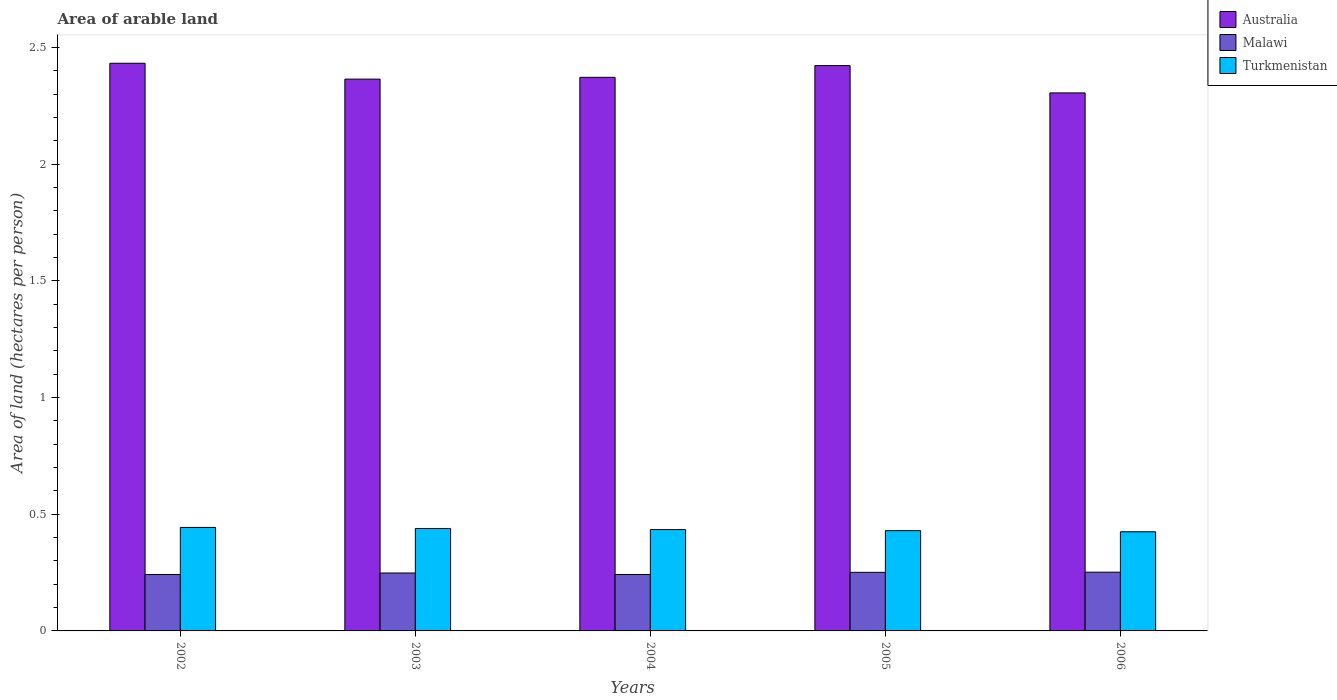Are the number of bars per tick equal to the number of legend labels?
Keep it short and to the point. Yes. Are the number of bars on each tick of the X-axis equal?
Offer a terse response. Yes. In how many cases, is the number of bars for a given year not equal to the number of legend labels?
Provide a succinct answer. 0. What is the total arable land in Turkmenistan in 2005?
Your response must be concise. 0.43. Across all years, what is the maximum total arable land in Malawi?
Your answer should be very brief. 0.25. Across all years, what is the minimum total arable land in Australia?
Your answer should be compact. 2.31. In which year was the total arable land in Malawi maximum?
Keep it short and to the point. 2006. What is the total total arable land in Australia in the graph?
Give a very brief answer. 11.9. What is the difference between the total arable land in Malawi in 2002 and that in 2003?
Make the answer very short. -0.01. What is the difference between the total arable land in Malawi in 2003 and the total arable land in Turkmenistan in 2005?
Provide a succinct answer. -0.18. What is the average total arable land in Malawi per year?
Make the answer very short. 0.25. In the year 2004, what is the difference between the total arable land in Turkmenistan and total arable land in Australia?
Offer a very short reply. -1.94. What is the ratio of the total arable land in Malawi in 2003 to that in 2005?
Your answer should be very brief. 0.99. Is the total arable land in Turkmenistan in 2003 less than that in 2006?
Provide a short and direct response. No. Is the difference between the total arable land in Turkmenistan in 2002 and 2005 greater than the difference between the total arable land in Australia in 2002 and 2005?
Keep it short and to the point. Yes. What is the difference between the highest and the second highest total arable land in Australia?
Keep it short and to the point. 0.01. What is the difference between the highest and the lowest total arable land in Turkmenistan?
Your answer should be compact. 0.02. Is the sum of the total arable land in Turkmenistan in 2005 and 2006 greater than the maximum total arable land in Australia across all years?
Provide a short and direct response. No. What does the 3rd bar from the left in 2006 represents?
Your response must be concise. Turkmenistan. Is it the case that in every year, the sum of the total arable land in Turkmenistan and total arable land in Australia is greater than the total arable land in Malawi?
Your answer should be compact. Yes. How many bars are there?
Your answer should be compact. 15. Are all the bars in the graph horizontal?
Ensure brevity in your answer.  No. Where does the legend appear in the graph?
Keep it short and to the point. Top right. What is the title of the graph?
Ensure brevity in your answer.  Area of arable land. Does "Belarus" appear as one of the legend labels in the graph?
Make the answer very short. No. What is the label or title of the X-axis?
Give a very brief answer. Years. What is the label or title of the Y-axis?
Your response must be concise. Area of land (hectares per person). What is the Area of land (hectares per person) of Australia in 2002?
Ensure brevity in your answer.  2.43. What is the Area of land (hectares per person) of Malawi in 2002?
Your response must be concise. 0.24. What is the Area of land (hectares per person) in Turkmenistan in 2002?
Your response must be concise. 0.44. What is the Area of land (hectares per person) in Australia in 2003?
Your answer should be very brief. 2.36. What is the Area of land (hectares per person) in Malawi in 2003?
Offer a very short reply. 0.25. What is the Area of land (hectares per person) of Turkmenistan in 2003?
Provide a short and direct response. 0.44. What is the Area of land (hectares per person) in Australia in 2004?
Provide a short and direct response. 2.37. What is the Area of land (hectares per person) of Malawi in 2004?
Provide a succinct answer. 0.24. What is the Area of land (hectares per person) in Turkmenistan in 2004?
Ensure brevity in your answer.  0.43. What is the Area of land (hectares per person) of Australia in 2005?
Offer a very short reply. 2.42. What is the Area of land (hectares per person) of Malawi in 2005?
Your answer should be compact. 0.25. What is the Area of land (hectares per person) in Turkmenistan in 2005?
Give a very brief answer. 0.43. What is the Area of land (hectares per person) in Australia in 2006?
Your answer should be compact. 2.31. What is the Area of land (hectares per person) of Malawi in 2006?
Provide a succinct answer. 0.25. What is the Area of land (hectares per person) of Turkmenistan in 2006?
Your response must be concise. 0.42. Across all years, what is the maximum Area of land (hectares per person) of Australia?
Your response must be concise. 2.43. Across all years, what is the maximum Area of land (hectares per person) in Malawi?
Provide a short and direct response. 0.25. Across all years, what is the maximum Area of land (hectares per person) in Turkmenistan?
Make the answer very short. 0.44. Across all years, what is the minimum Area of land (hectares per person) in Australia?
Offer a terse response. 2.31. Across all years, what is the minimum Area of land (hectares per person) in Malawi?
Provide a short and direct response. 0.24. Across all years, what is the minimum Area of land (hectares per person) of Turkmenistan?
Make the answer very short. 0.42. What is the total Area of land (hectares per person) of Australia in the graph?
Keep it short and to the point. 11.9. What is the total Area of land (hectares per person) in Malawi in the graph?
Your answer should be very brief. 1.23. What is the total Area of land (hectares per person) of Turkmenistan in the graph?
Your response must be concise. 2.17. What is the difference between the Area of land (hectares per person) in Australia in 2002 and that in 2003?
Your answer should be compact. 0.07. What is the difference between the Area of land (hectares per person) of Malawi in 2002 and that in 2003?
Ensure brevity in your answer.  -0.01. What is the difference between the Area of land (hectares per person) in Turkmenistan in 2002 and that in 2003?
Your answer should be very brief. 0. What is the difference between the Area of land (hectares per person) in Australia in 2002 and that in 2004?
Give a very brief answer. 0.06. What is the difference between the Area of land (hectares per person) of Turkmenistan in 2002 and that in 2004?
Keep it short and to the point. 0.01. What is the difference between the Area of land (hectares per person) in Australia in 2002 and that in 2005?
Provide a short and direct response. 0.01. What is the difference between the Area of land (hectares per person) of Malawi in 2002 and that in 2005?
Offer a very short reply. -0.01. What is the difference between the Area of land (hectares per person) in Turkmenistan in 2002 and that in 2005?
Your response must be concise. 0.01. What is the difference between the Area of land (hectares per person) in Australia in 2002 and that in 2006?
Offer a terse response. 0.13. What is the difference between the Area of land (hectares per person) in Malawi in 2002 and that in 2006?
Offer a terse response. -0.01. What is the difference between the Area of land (hectares per person) of Turkmenistan in 2002 and that in 2006?
Keep it short and to the point. 0.02. What is the difference between the Area of land (hectares per person) of Australia in 2003 and that in 2004?
Offer a terse response. -0.01. What is the difference between the Area of land (hectares per person) of Malawi in 2003 and that in 2004?
Keep it short and to the point. 0.01. What is the difference between the Area of land (hectares per person) in Turkmenistan in 2003 and that in 2004?
Ensure brevity in your answer.  0. What is the difference between the Area of land (hectares per person) in Australia in 2003 and that in 2005?
Offer a very short reply. -0.06. What is the difference between the Area of land (hectares per person) in Malawi in 2003 and that in 2005?
Your answer should be compact. -0. What is the difference between the Area of land (hectares per person) of Turkmenistan in 2003 and that in 2005?
Provide a succinct answer. 0.01. What is the difference between the Area of land (hectares per person) in Australia in 2003 and that in 2006?
Your answer should be very brief. 0.06. What is the difference between the Area of land (hectares per person) in Malawi in 2003 and that in 2006?
Keep it short and to the point. -0. What is the difference between the Area of land (hectares per person) in Turkmenistan in 2003 and that in 2006?
Your answer should be very brief. 0.01. What is the difference between the Area of land (hectares per person) in Australia in 2004 and that in 2005?
Keep it short and to the point. -0.05. What is the difference between the Area of land (hectares per person) of Malawi in 2004 and that in 2005?
Your response must be concise. -0.01. What is the difference between the Area of land (hectares per person) in Turkmenistan in 2004 and that in 2005?
Your response must be concise. 0. What is the difference between the Area of land (hectares per person) of Australia in 2004 and that in 2006?
Keep it short and to the point. 0.07. What is the difference between the Area of land (hectares per person) of Malawi in 2004 and that in 2006?
Your answer should be very brief. -0.01. What is the difference between the Area of land (hectares per person) in Turkmenistan in 2004 and that in 2006?
Provide a short and direct response. 0.01. What is the difference between the Area of land (hectares per person) in Australia in 2005 and that in 2006?
Your answer should be very brief. 0.12. What is the difference between the Area of land (hectares per person) of Malawi in 2005 and that in 2006?
Provide a succinct answer. -0. What is the difference between the Area of land (hectares per person) of Turkmenistan in 2005 and that in 2006?
Provide a short and direct response. 0. What is the difference between the Area of land (hectares per person) of Australia in 2002 and the Area of land (hectares per person) of Malawi in 2003?
Make the answer very short. 2.18. What is the difference between the Area of land (hectares per person) in Australia in 2002 and the Area of land (hectares per person) in Turkmenistan in 2003?
Make the answer very short. 1.99. What is the difference between the Area of land (hectares per person) in Malawi in 2002 and the Area of land (hectares per person) in Turkmenistan in 2003?
Give a very brief answer. -0.2. What is the difference between the Area of land (hectares per person) of Australia in 2002 and the Area of land (hectares per person) of Malawi in 2004?
Keep it short and to the point. 2.19. What is the difference between the Area of land (hectares per person) in Australia in 2002 and the Area of land (hectares per person) in Turkmenistan in 2004?
Ensure brevity in your answer.  2. What is the difference between the Area of land (hectares per person) of Malawi in 2002 and the Area of land (hectares per person) of Turkmenistan in 2004?
Make the answer very short. -0.19. What is the difference between the Area of land (hectares per person) of Australia in 2002 and the Area of land (hectares per person) of Malawi in 2005?
Provide a succinct answer. 2.18. What is the difference between the Area of land (hectares per person) of Australia in 2002 and the Area of land (hectares per person) of Turkmenistan in 2005?
Provide a succinct answer. 2. What is the difference between the Area of land (hectares per person) of Malawi in 2002 and the Area of land (hectares per person) of Turkmenistan in 2005?
Your answer should be very brief. -0.19. What is the difference between the Area of land (hectares per person) in Australia in 2002 and the Area of land (hectares per person) in Malawi in 2006?
Make the answer very short. 2.18. What is the difference between the Area of land (hectares per person) of Australia in 2002 and the Area of land (hectares per person) of Turkmenistan in 2006?
Make the answer very short. 2.01. What is the difference between the Area of land (hectares per person) of Malawi in 2002 and the Area of land (hectares per person) of Turkmenistan in 2006?
Your answer should be very brief. -0.18. What is the difference between the Area of land (hectares per person) in Australia in 2003 and the Area of land (hectares per person) in Malawi in 2004?
Keep it short and to the point. 2.12. What is the difference between the Area of land (hectares per person) in Australia in 2003 and the Area of land (hectares per person) in Turkmenistan in 2004?
Offer a very short reply. 1.93. What is the difference between the Area of land (hectares per person) in Malawi in 2003 and the Area of land (hectares per person) in Turkmenistan in 2004?
Offer a terse response. -0.19. What is the difference between the Area of land (hectares per person) of Australia in 2003 and the Area of land (hectares per person) of Malawi in 2005?
Your answer should be very brief. 2.11. What is the difference between the Area of land (hectares per person) of Australia in 2003 and the Area of land (hectares per person) of Turkmenistan in 2005?
Make the answer very short. 1.93. What is the difference between the Area of land (hectares per person) in Malawi in 2003 and the Area of land (hectares per person) in Turkmenistan in 2005?
Your response must be concise. -0.18. What is the difference between the Area of land (hectares per person) in Australia in 2003 and the Area of land (hectares per person) in Malawi in 2006?
Offer a very short reply. 2.11. What is the difference between the Area of land (hectares per person) of Australia in 2003 and the Area of land (hectares per person) of Turkmenistan in 2006?
Keep it short and to the point. 1.94. What is the difference between the Area of land (hectares per person) of Malawi in 2003 and the Area of land (hectares per person) of Turkmenistan in 2006?
Give a very brief answer. -0.18. What is the difference between the Area of land (hectares per person) in Australia in 2004 and the Area of land (hectares per person) in Malawi in 2005?
Provide a short and direct response. 2.12. What is the difference between the Area of land (hectares per person) in Australia in 2004 and the Area of land (hectares per person) in Turkmenistan in 2005?
Keep it short and to the point. 1.94. What is the difference between the Area of land (hectares per person) in Malawi in 2004 and the Area of land (hectares per person) in Turkmenistan in 2005?
Give a very brief answer. -0.19. What is the difference between the Area of land (hectares per person) in Australia in 2004 and the Area of land (hectares per person) in Malawi in 2006?
Provide a short and direct response. 2.12. What is the difference between the Area of land (hectares per person) of Australia in 2004 and the Area of land (hectares per person) of Turkmenistan in 2006?
Provide a succinct answer. 1.95. What is the difference between the Area of land (hectares per person) in Malawi in 2004 and the Area of land (hectares per person) in Turkmenistan in 2006?
Your response must be concise. -0.18. What is the difference between the Area of land (hectares per person) in Australia in 2005 and the Area of land (hectares per person) in Malawi in 2006?
Ensure brevity in your answer.  2.17. What is the difference between the Area of land (hectares per person) of Australia in 2005 and the Area of land (hectares per person) of Turkmenistan in 2006?
Ensure brevity in your answer.  2. What is the difference between the Area of land (hectares per person) of Malawi in 2005 and the Area of land (hectares per person) of Turkmenistan in 2006?
Keep it short and to the point. -0.17. What is the average Area of land (hectares per person) in Australia per year?
Make the answer very short. 2.38. What is the average Area of land (hectares per person) of Malawi per year?
Provide a succinct answer. 0.25. What is the average Area of land (hectares per person) in Turkmenistan per year?
Ensure brevity in your answer.  0.43. In the year 2002, what is the difference between the Area of land (hectares per person) of Australia and Area of land (hectares per person) of Malawi?
Give a very brief answer. 2.19. In the year 2002, what is the difference between the Area of land (hectares per person) in Australia and Area of land (hectares per person) in Turkmenistan?
Your response must be concise. 1.99. In the year 2002, what is the difference between the Area of land (hectares per person) of Malawi and Area of land (hectares per person) of Turkmenistan?
Offer a very short reply. -0.2. In the year 2003, what is the difference between the Area of land (hectares per person) of Australia and Area of land (hectares per person) of Malawi?
Your response must be concise. 2.12. In the year 2003, what is the difference between the Area of land (hectares per person) in Australia and Area of land (hectares per person) in Turkmenistan?
Keep it short and to the point. 1.93. In the year 2003, what is the difference between the Area of land (hectares per person) of Malawi and Area of land (hectares per person) of Turkmenistan?
Provide a short and direct response. -0.19. In the year 2004, what is the difference between the Area of land (hectares per person) of Australia and Area of land (hectares per person) of Malawi?
Your answer should be very brief. 2.13. In the year 2004, what is the difference between the Area of land (hectares per person) of Australia and Area of land (hectares per person) of Turkmenistan?
Make the answer very short. 1.94. In the year 2004, what is the difference between the Area of land (hectares per person) of Malawi and Area of land (hectares per person) of Turkmenistan?
Give a very brief answer. -0.19. In the year 2005, what is the difference between the Area of land (hectares per person) of Australia and Area of land (hectares per person) of Malawi?
Provide a short and direct response. 2.17. In the year 2005, what is the difference between the Area of land (hectares per person) of Australia and Area of land (hectares per person) of Turkmenistan?
Offer a very short reply. 1.99. In the year 2005, what is the difference between the Area of land (hectares per person) of Malawi and Area of land (hectares per person) of Turkmenistan?
Ensure brevity in your answer.  -0.18. In the year 2006, what is the difference between the Area of land (hectares per person) of Australia and Area of land (hectares per person) of Malawi?
Your answer should be very brief. 2.05. In the year 2006, what is the difference between the Area of land (hectares per person) of Australia and Area of land (hectares per person) of Turkmenistan?
Make the answer very short. 1.88. In the year 2006, what is the difference between the Area of land (hectares per person) in Malawi and Area of land (hectares per person) in Turkmenistan?
Make the answer very short. -0.17. What is the ratio of the Area of land (hectares per person) in Australia in 2002 to that in 2003?
Give a very brief answer. 1.03. What is the ratio of the Area of land (hectares per person) in Malawi in 2002 to that in 2003?
Provide a short and direct response. 0.97. What is the ratio of the Area of land (hectares per person) in Turkmenistan in 2002 to that in 2003?
Offer a very short reply. 1.01. What is the ratio of the Area of land (hectares per person) of Australia in 2002 to that in 2004?
Offer a terse response. 1.03. What is the ratio of the Area of land (hectares per person) of Australia in 2002 to that in 2005?
Provide a succinct answer. 1. What is the ratio of the Area of land (hectares per person) in Malawi in 2002 to that in 2005?
Your answer should be compact. 0.96. What is the ratio of the Area of land (hectares per person) in Turkmenistan in 2002 to that in 2005?
Ensure brevity in your answer.  1.03. What is the ratio of the Area of land (hectares per person) in Australia in 2002 to that in 2006?
Provide a succinct answer. 1.06. What is the ratio of the Area of land (hectares per person) of Malawi in 2002 to that in 2006?
Give a very brief answer. 0.96. What is the ratio of the Area of land (hectares per person) in Turkmenistan in 2002 to that in 2006?
Your answer should be very brief. 1.04. What is the ratio of the Area of land (hectares per person) of Malawi in 2003 to that in 2004?
Make the answer very short. 1.03. What is the ratio of the Area of land (hectares per person) in Turkmenistan in 2003 to that in 2004?
Offer a terse response. 1.01. What is the ratio of the Area of land (hectares per person) of Australia in 2003 to that in 2005?
Offer a terse response. 0.98. What is the ratio of the Area of land (hectares per person) of Turkmenistan in 2003 to that in 2005?
Provide a succinct answer. 1.02. What is the ratio of the Area of land (hectares per person) in Australia in 2003 to that in 2006?
Provide a short and direct response. 1.03. What is the ratio of the Area of land (hectares per person) in Malawi in 2003 to that in 2006?
Make the answer very short. 0.99. What is the ratio of the Area of land (hectares per person) of Turkmenistan in 2003 to that in 2006?
Your answer should be compact. 1.03. What is the ratio of the Area of land (hectares per person) in Australia in 2004 to that in 2005?
Ensure brevity in your answer.  0.98. What is the ratio of the Area of land (hectares per person) of Malawi in 2004 to that in 2005?
Your response must be concise. 0.96. What is the ratio of the Area of land (hectares per person) of Turkmenistan in 2004 to that in 2005?
Your response must be concise. 1.01. What is the ratio of the Area of land (hectares per person) of Australia in 2004 to that in 2006?
Your response must be concise. 1.03. What is the ratio of the Area of land (hectares per person) of Malawi in 2004 to that in 2006?
Your answer should be compact. 0.96. What is the ratio of the Area of land (hectares per person) in Turkmenistan in 2004 to that in 2006?
Provide a short and direct response. 1.02. What is the ratio of the Area of land (hectares per person) in Australia in 2005 to that in 2006?
Your answer should be compact. 1.05. What is the ratio of the Area of land (hectares per person) in Malawi in 2005 to that in 2006?
Offer a terse response. 1. What is the ratio of the Area of land (hectares per person) of Turkmenistan in 2005 to that in 2006?
Ensure brevity in your answer.  1.01. What is the difference between the highest and the second highest Area of land (hectares per person) in Australia?
Provide a short and direct response. 0.01. What is the difference between the highest and the second highest Area of land (hectares per person) in Malawi?
Give a very brief answer. 0. What is the difference between the highest and the second highest Area of land (hectares per person) in Turkmenistan?
Provide a short and direct response. 0. What is the difference between the highest and the lowest Area of land (hectares per person) of Australia?
Offer a terse response. 0.13. What is the difference between the highest and the lowest Area of land (hectares per person) of Malawi?
Offer a very short reply. 0.01. What is the difference between the highest and the lowest Area of land (hectares per person) in Turkmenistan?
Offer a very short reply. 0.02. 